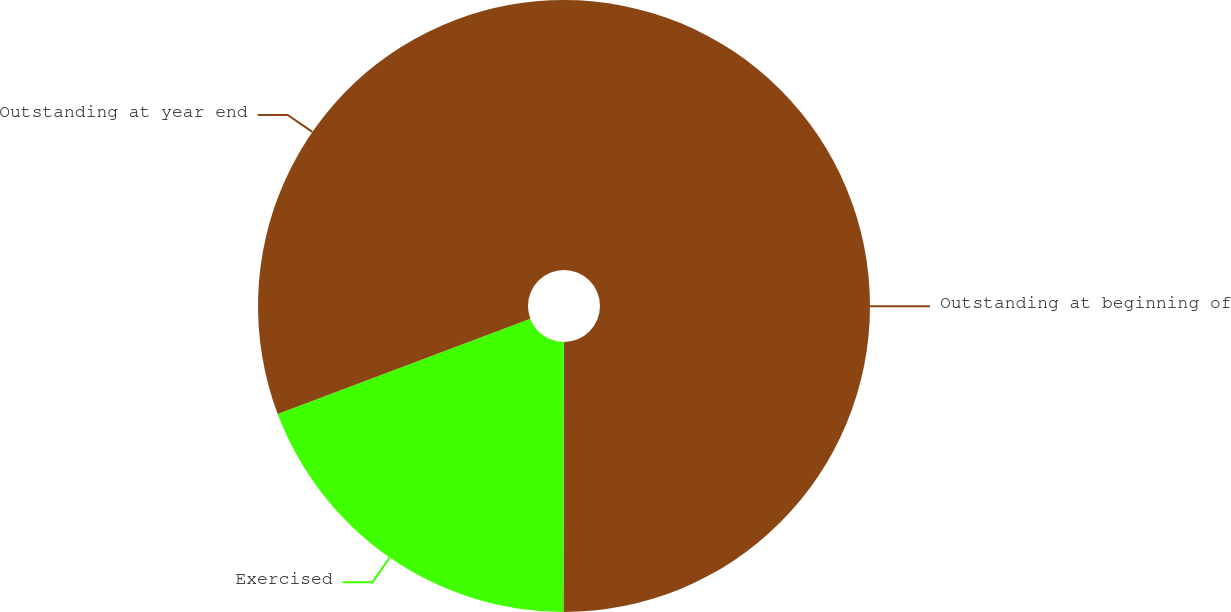Convert chart to OTSL. <chart><loc_0><loc_0><loc_500><loc_500><pie_chart><fcel>Outstanding at beginning of<fcel>Exercised<fcel>Outstanding at year end<nl><fcel>50.03%<fcel>19.23%<fcel>30.74%<nl></chart> 